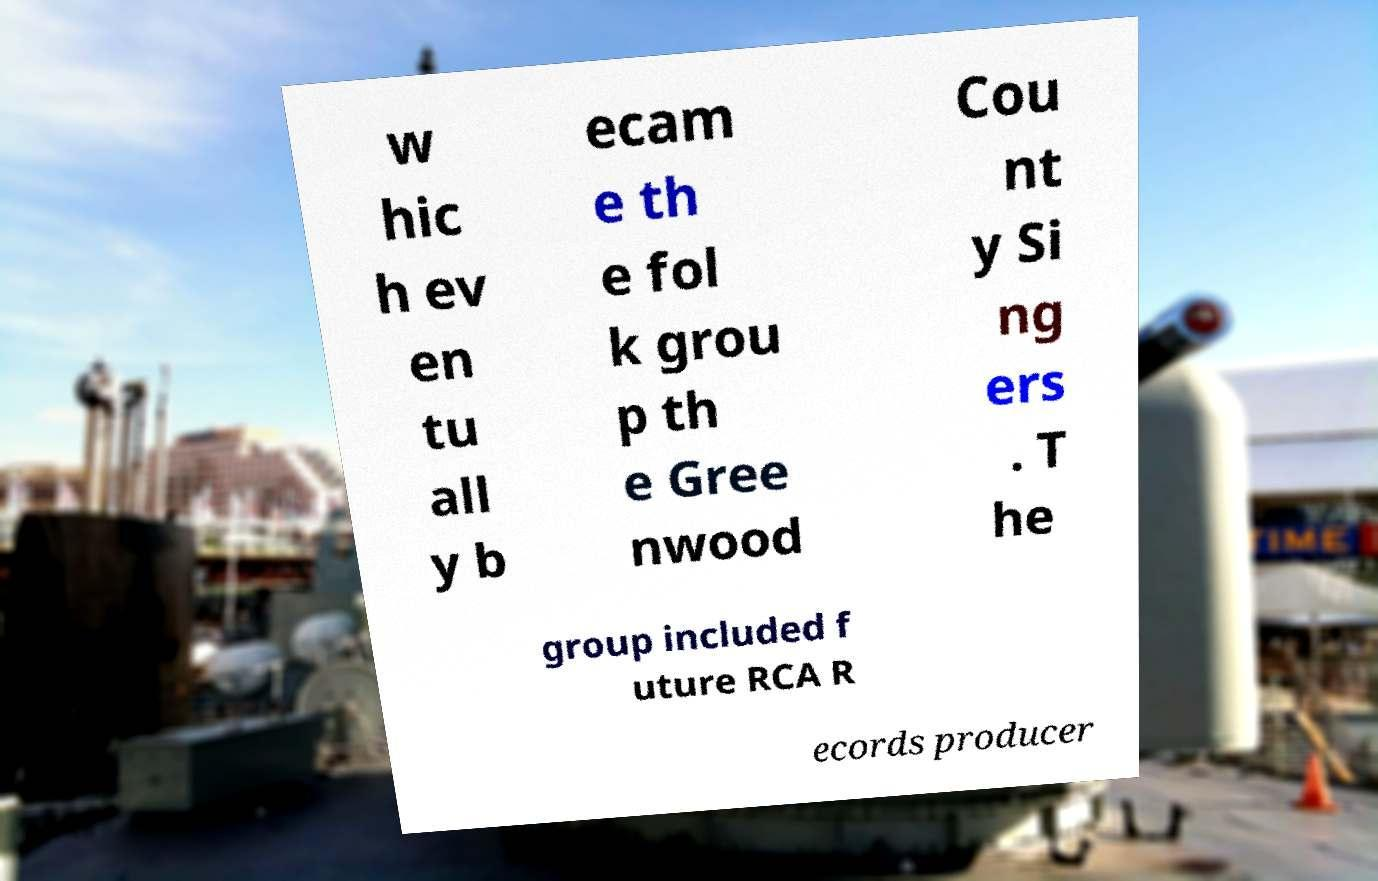Can you accurately transcribe the text from the provided image for me? w hic h ev en tu all y b ecam e th e fol k grou p th e Gree nwood Cou nt y Si ng ers . T he group included f uture RCA R ecords producer 